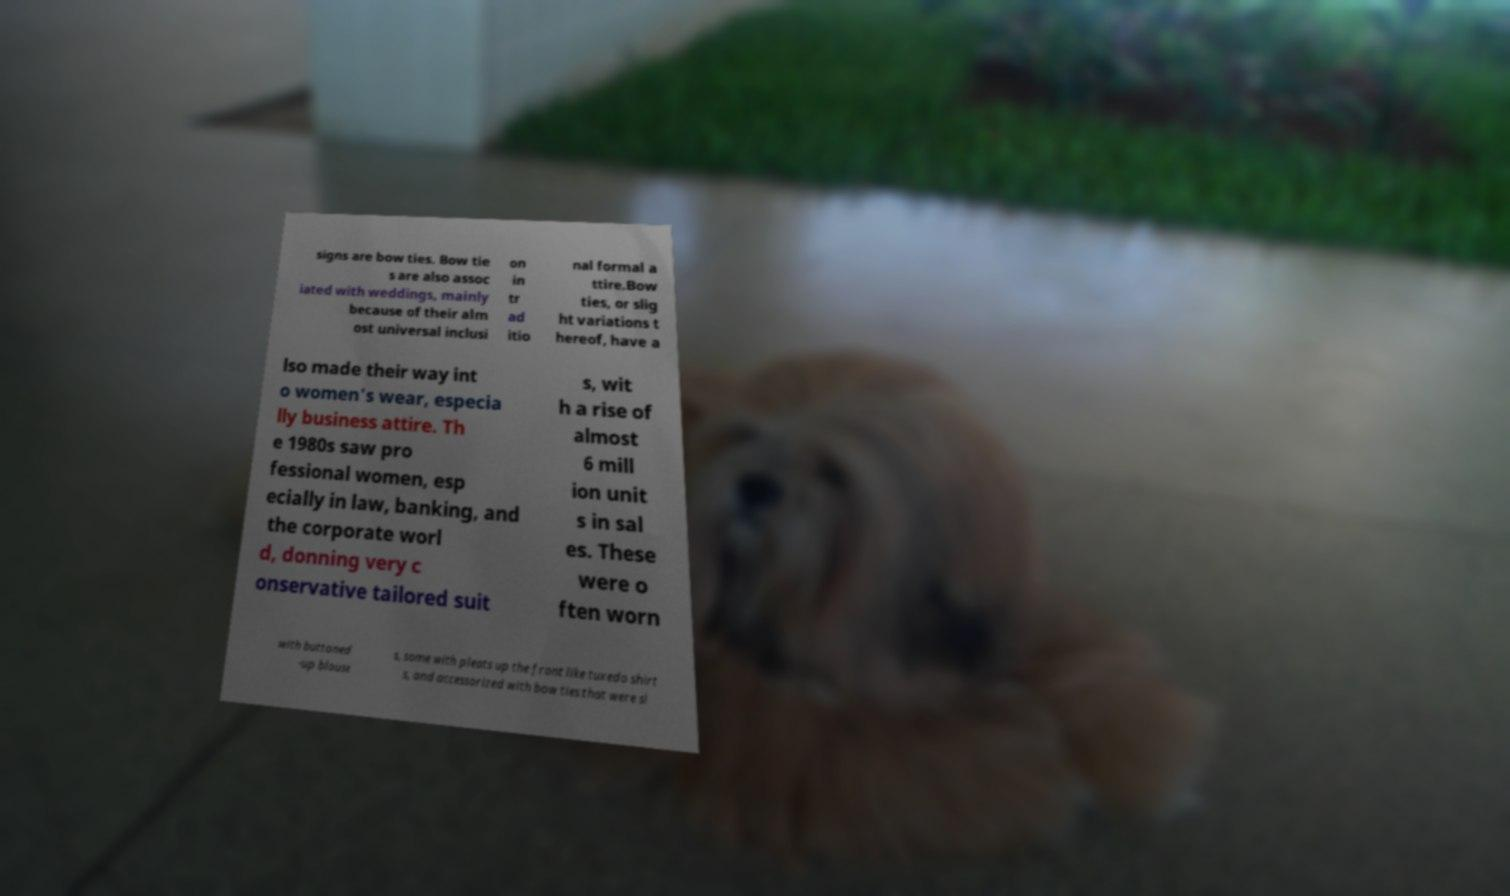What messages or text are displayed in this image? I need them in a readable, typed format. signs are bow ties. Bow tie s are also assoc iated with weddings, mainly because of their alm ost universal inclusi on in tr ad itio nal formal a ttire.Bow ties, or slig ht variations t hereof, have a lso made their way int o women's wear, especia lly business attire. Th e 1980s saw pro fessional women, esp ecially in law, banking, and the corporate worl d, donning very c onservative tailored suit s, wit h a rise of almost 6 mill ion unit s in sal es. These were o ften worn with buttoned -up blouse s, some with pleats up the front like tuxedo shirt s, and accessorized with bow ties that were sl 